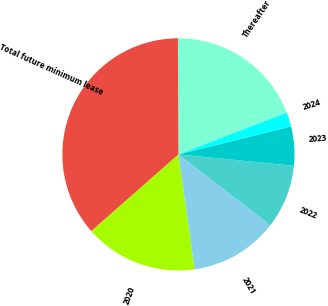Convert chart to OTSL. <chart><loc_0><loc_0><loc_500><loc_500><pie_chart><fcel>2020<fcel>2021<fcel>2022<fcel>2023<fcel>2024<fcel>Thereafter<fcel>Total future minimum lease<nl><fcel>15.76%<fcel>12.32%<fcel>8.88%<fcel>5.44%<fcel>2.0%<fcel>19.2%<fcel>36.4%<nl></chart> 